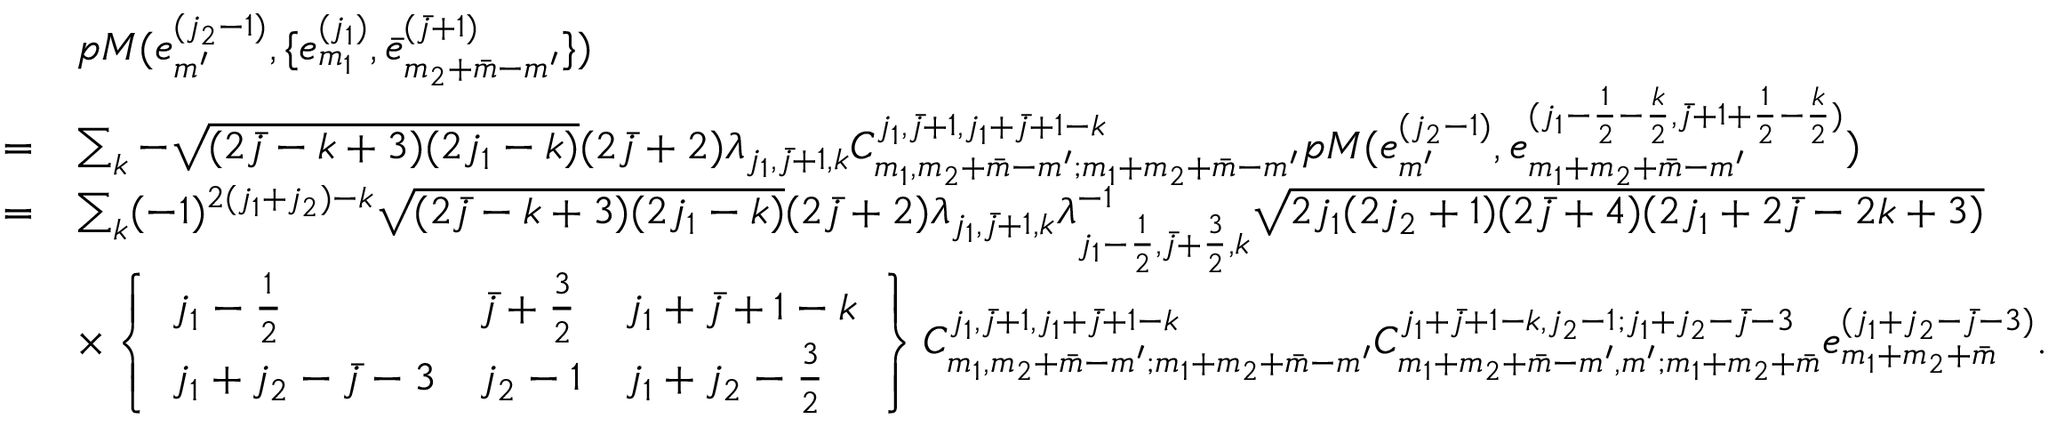<formula> <loc_0><loc_0><loc_500><loc_500>\begin{array} { r l } & { p M ( e _ { m ^ { \prime } } ^ { ( j _ { 2 } - 1 ) } , \{ e _ { m _ { 1 } } ^ { ( j _ { 1 } ) } , \bar { e } _ { m _ { 2 } + \bar { m } - m ^ { \prime } } ^ { ( \bar { j } + 1 ) } \} ) } \\ { = } & { \sum _ { k } - \sqrt { ( 2 \bar { j } - k + 3 ) ( 2 j _ { 1 } - k ) } ( 2 \bar { j } + 2 ) \lambda _ { j _ { 1 } , \bar { j } + 1 , k } C _ { m _ { 1 } , m _ { 2 } + \bar { m } - m ^ { \prime } ; m _ { 1 } + m _ { 2 } + \bar { m } - m ^ { \prime } } ^ { j _ { 1 } , \bar { j } + 1 , j _ { 1 } + \bar { j } + 1 - k } p M ( e _ { m ^ { \prime } } ^ { ( j _ { 2 } - 1 ) } , e _ { m _ { 1 } + m _ { 2 } + \bar { m } - m ^ { \prime } } ^ { ( j _ { 1 } - \frac { 1 } { 2 } - \frac { k } { 2 } , \bar { j } + 1 + \frac { 1 } { 2 } - \frac { k } { 2 } ) } ) } \\ { = } & { \sum _ { k } ( - 1 ) ^ { 2 ( j _ { 1 } + j _ { 2 } ) - k } \sqrt { ( 2 \bar { j } - k + 3 ) ( 2 j _ { 1 } - k ) } ( 2 \bar { j } + 2 ) \lambda _ { j _ { 1 } , \bar { j } + 1 , k } \lambda _ { j _ { 1 } - \frac { 1 } { 2 } , \bar { j } + \frac { 3 } { 2 } , k } ^ { - 1 } \sqrt { 2 j _ { 1 } ( 2 j _ { 2 } + 1 ) ( 2 \bar { j } + 4 ) ( 2 j _ { 1 } + 2 \bar { j } - 2 k + 3 ) } } \\ & { \times \left \{ \begin{array} { l l l } { j _ { 1 } - \frac { 1 } { 2 } } & { \bar { j } + \frac { 3 } { 2 } } & { j _ { 1 } + \bar { j } + 1 - k } \\ { j _ { 1 } + j _ { 2 } - \bar { j } - 3 } & { j _ { 2 } - 1 } & { j _ { 1 } + j _ { 2 } - \frac { 3 } { 2 } } \end{array} \right \} C _ { m _ { 1 } , m _ { 2 } + \bar { m } - m ^ { \prime } ; m _ { 1 } + m _ { 2 } + \bar { m } - m ^ { \prime } } ^ { j _ { 1 } , \bar { j } + 1 , j _ { 1 } + \bar { j } + 1 - k } C _ { m _ { 1 } + m _ { 2 } + \bar { m } - m ^ { \prime } , m ^ { \prime } ; m _ { 1 } + m _ { 2 } + \bar { m } } ^ { j _ { 1 } + \bar { j } + 1 - k , j _ { 2 } - 1 ; j _ { 1 } + j _ { 2 } - \bar { j } - 3 } e _ { m _ { 1 } + m _ { 2 } + \bar { m } } ^ { ( j _ { 1 } + j _ { 2 } - \bar { j } - 3 ) } . } \end{array}</formula> 